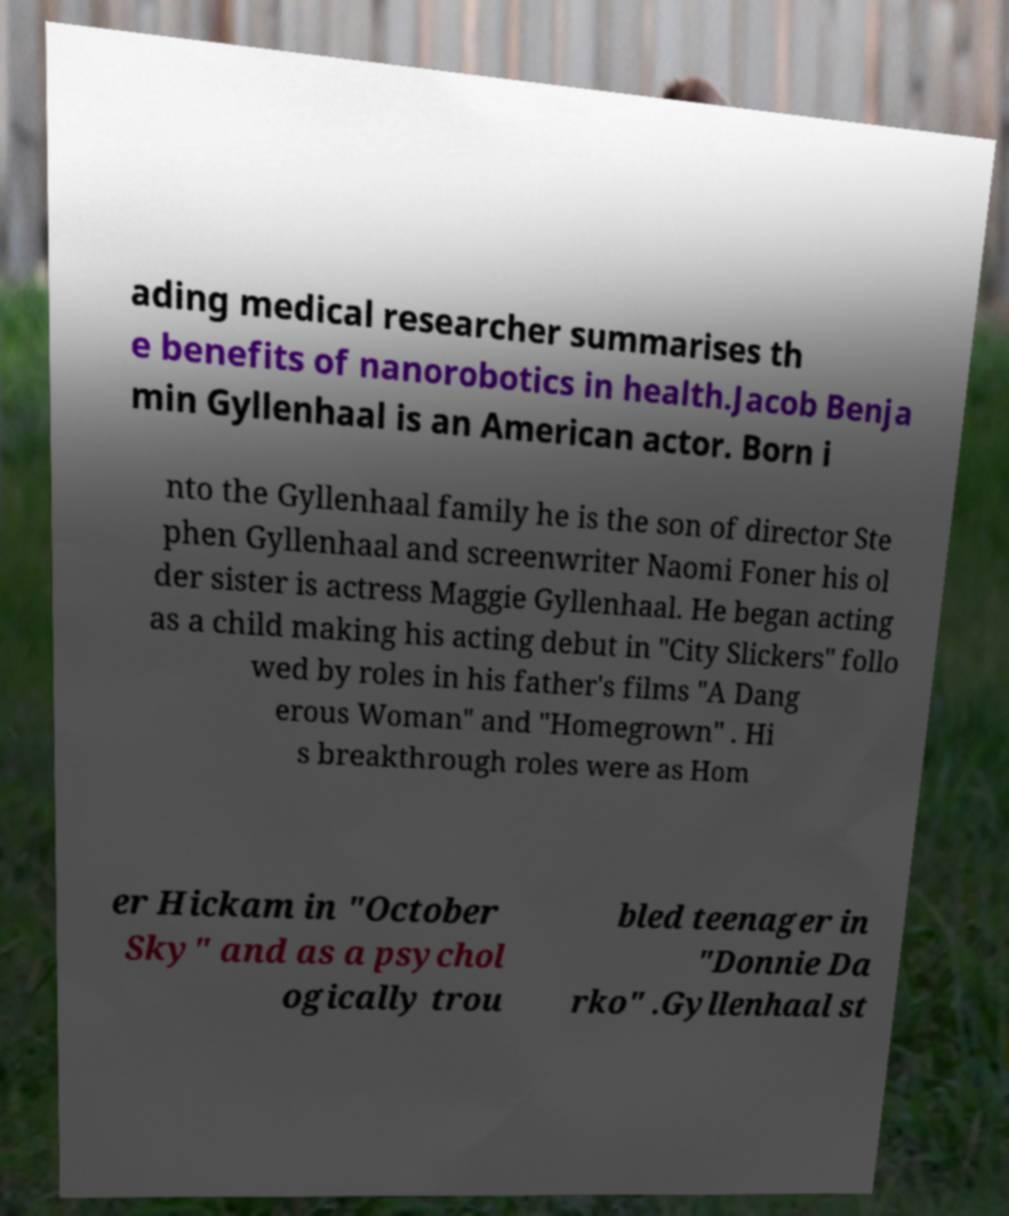Can you read and provide the text displayed in the image?This photo seems to have some interesting text. Can you extract and type it out for me? ading medical researcher summarises th e benefits of nanorobotics in health.Jacob Benja min Gyllenhaal is an American actor. Born i nto the Gyllenhaal family he is the son of director Ste phen Gyllenhaal and screenwriter Naomi Foner his ol der sister is actress Maggie Gyllenhaal. He began acting as a child making his acting debut in "City Slickers" follo wed by roles in his father's films "A Dang erous Woman" and "Homegrown" . Hi s breakthrough roles were as Hom er Hickam in "October Sky" and as a psychol ogically trou bled teenager in "Donnie Da rko" .Gyllenhaal st 